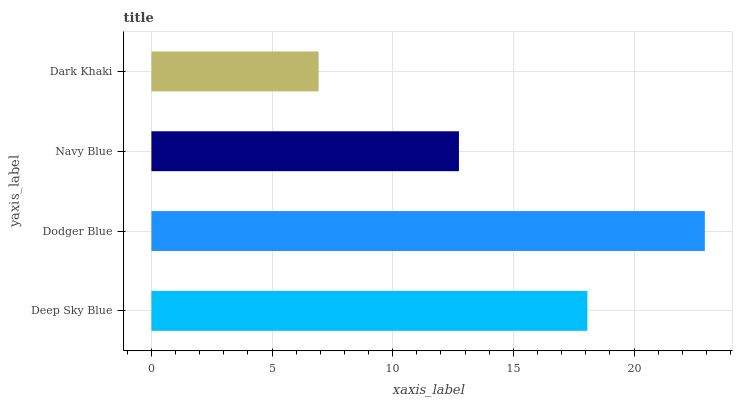Is Dark Khaki the minimum?
Answer yes or no. Yes. Is Dodger Blue the maximum?
Answer yes or no. Yes. Is Navy Blue the minimum?
Answer yes or no. No. Is Navy Blue the maximum?
Answer yes or no. No. Is Dodger Blue greater than Navy Blue?
Answer yes or no. Yes. Is Navy Blue less than Dodger Blue?
Answer yes or no. Yes. Is Navy Blue greater than Dodger Blue?
Answer yes or no. No. Is Dodger Blue less than Navy Blue?
Answer yes or no. No. Is Deep Sky Blue the high median?
Answer yes or no. Yes. Is Navy Blue the low median?
Answer yes or no. Yes. Is Dodger Blue the high median?
Answer yes or no. No. Is Deep Sky Blue the low median?
Answer yes or no. No. 